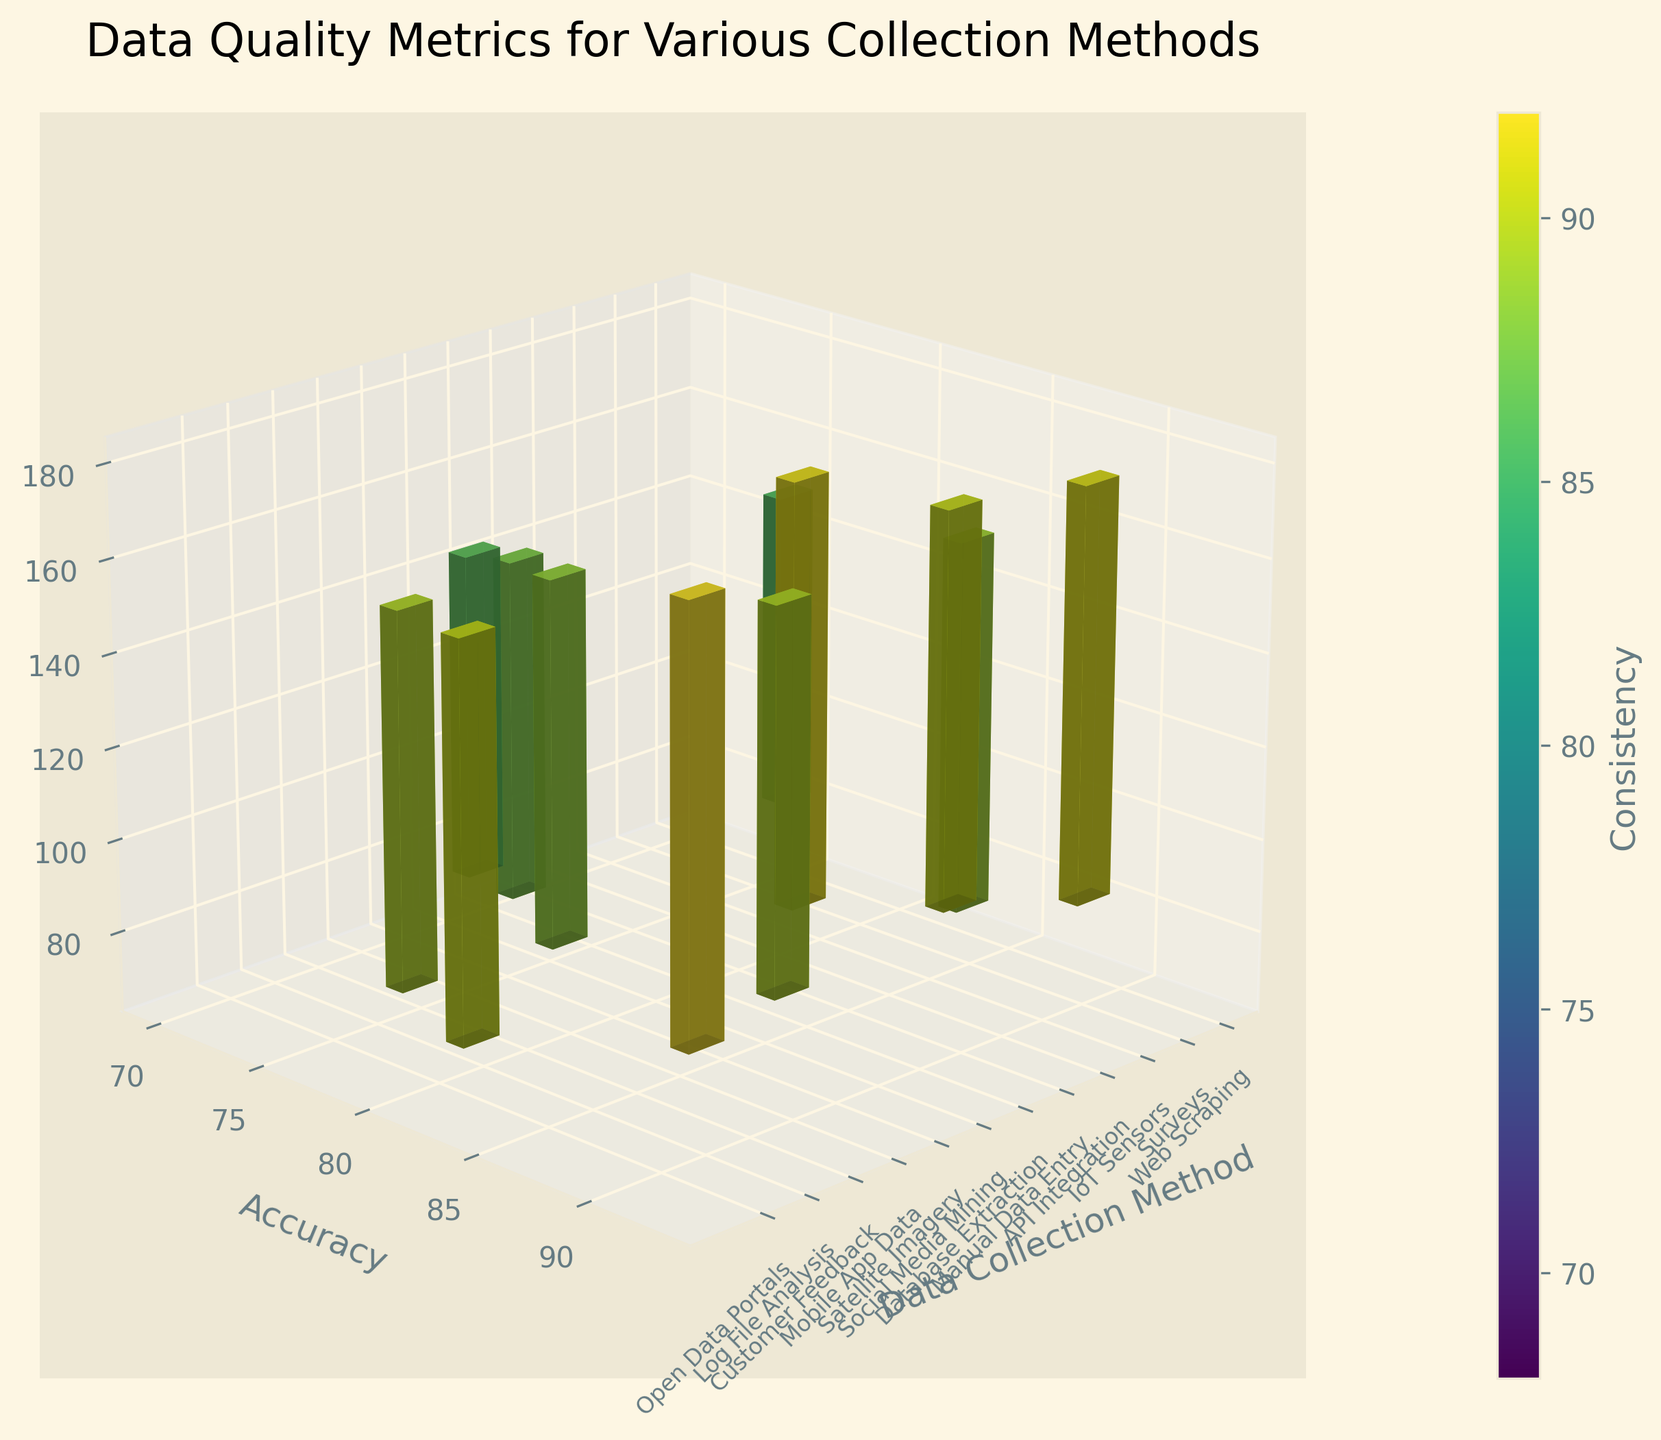What's the highest value for accuracy among the data collection methods? By examining the 'Accuracy' dimension, the IoT Sensors method has the highest value at 92.
Answer: IoT Sensors What's the range of completeness values across all methods? The completeness values range from the minimum value of 65 (Manual Data Entry) to the maximum value of 95 (IoT Sensors). Therefore, the range is 95 - 65 = 30.
Answer: 30 Which data collection method has the least consistency? Looking at the 'Consistency' axis, Manual Data Entry has the lowest consistency value at 75.
Answer: Manual Data Entry What methods have both accuracy and completeness greater than 85? By analyzing the 3D bar plot, IoT Sensors (Accuracy: 92, Completeness: 95), API Integration (Accuracy: 88, Completeness: 90), and Database Extraction (Accuracy: 85, Completeness: 92) meet these criteria.
Answer: IoT Sensors, API Integration, Database Extraction What is the average consistency of the methods with accuracy above 80? Methods with accuracy above 80 are Surveys (Consistency: 80), IoT Sensors (Consistency: 88), API Integration (Consistency: 85), Database Extraction (Consistency: 90), Satellite Imagery (Consistency: 82), Log File Analysis (Consistency: 92), and Open Data Portals (Consistency: 85). Sum these values: 80 + 88 + 85 + 90 + 82 + 92 + 85 = 602. The average is 602 / 7 = 86.
Answer: 86 Which method lies closest to the average completeness of all methods? Calculate average completeness: (82+78+95+90+65+92+80+85+85+70+88+78) / 12 = 81.83. The Social Media Mining method (completeness: 80) lies closest to this average.
Answer: Social Media Mining What is the difference in completeness between the highest and lowest consistency methods? The highest consistency method, Log File Analysis, has a completeness value of 88. The lowest consistency method, Manual Data Entry, has a completeness value of 65. Therefore, the difference is 88 - 65 = 23.
Answer: 23 Is there any method where all three metrics (accuracy, completeness, consistency) are equal? By inspecting the plot, no method has equal values across all three dimensions (accuracy, completeness, consistency).
Answer: No Which method falls under the maximum range of all three metrics individually? Max ranges: Accuracy (92), Completeness (95), Consistency (92). IoT Sensors fall under this for accuracy and completeness, Log File Analysis for consistency.
Answer: IoT Sensors, Log File Analysis Compare the consistency of Mobile App Data and Customer Feedback data collection methods. Which one is higher? By observing the 'Consistency' axis, Mobile App Data has a consistency value of 78, while Customer Feedback has 82. Therefore, Customer Feedback's consistency is higher.
Answer: Customer Feedback 